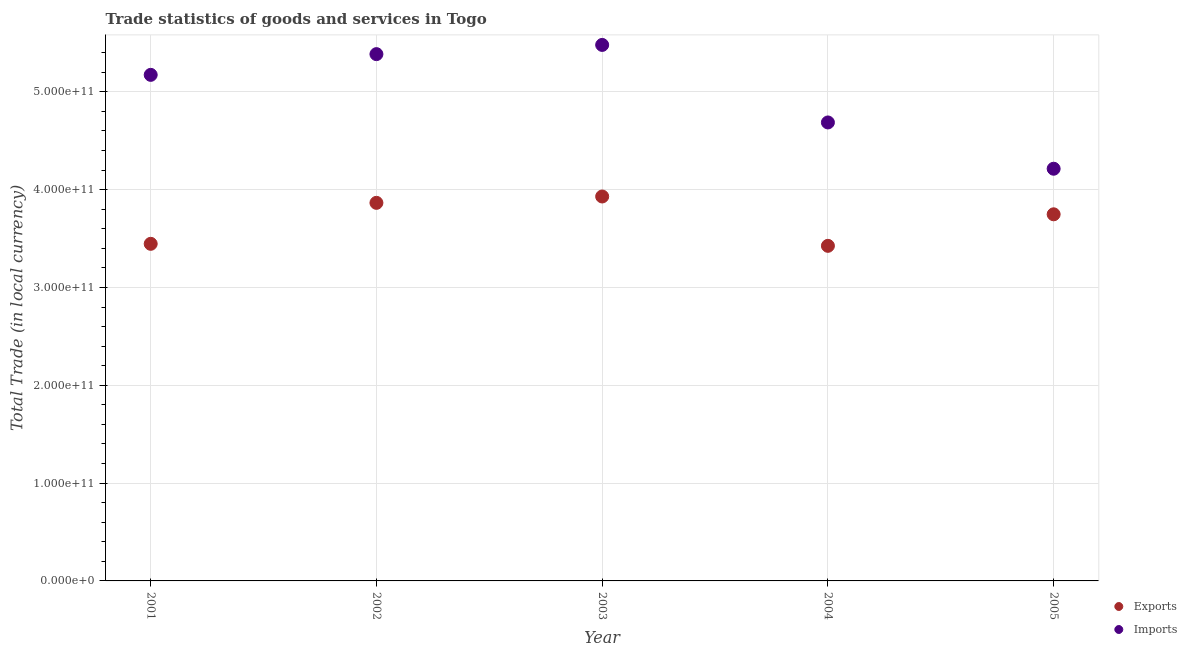How many different coloured dotlines are there?
Ensure brevity in your answer.  2. Is the number of dotlines equal to the number of legend labels?
Offer a terse response. Yes. What is the export of goods and services in 2001?
Give a very brief answer. 3.45e+11. Across all years, what is the maximum export of goods and services?
Give a very brief answer. 3.93e+11. Across all years, what is the minimum export of goods and services?
Make the answer very short. 3.43e+11. In which year was the imports of goods and services maximum?
Offer a terse response. 2003. What is the total imports of goods and services in the graph?
Your response must be concise. 2.49e+12. What is the difference between the imports of goods and services in 2002 and that in 2005?
Make the answer very short. 1.17e+11. What is the difference between the export of goods and services in 2004 and the imports of goods and services in 2005?
Offer a very short reply. -7.88e+1. What is the average export of goods and services per year?
Your answer should be compact. 3.68e+11. In the year 2004, what is the difference between the imports of goods and services and export of goods and services?
Offer a terse response. 1.26e+11. What is the ratio of the export of goods and services in 2001 to that in 2002?
Provide a short and direct response. 0.89. What is the difference between the highest and the second highest imports of goods and services?
Your answer should be very brief. 9.42e+09. What is the difference between the highest and the lowest imports of goods and services?
Your answer should be compact. 1.27e+11. Is the export of goods and services strictly less than the imports of goods and services over the years?
Offer a terse response. Yes. How many dotlines are there?
Provide a short and direct response. 2. What is the difference between two consecutive major ticks on the Y-axis?
Your answer should be compact. 1.00e+11. Does the graph contain any zero values?
Ensure brevity in your answer.  No. Does the graph contain grids?
Offer a very short reply. Yes. Where does the legend appear in the graph?
Offer a terse response. Bottom right. How many legend labels are there?
Your answer should be compact. 2. How are the legend labels stacked?
Give a very brief answer. Vertical. What is the title of the graph?
Keep it short and to the point. Trade statistics of goods and services in Togo. Does "Banks" appear as one of the legend labels in the graph?
Offer a very short reply. No. What is the label or title of the Y-axis?
Give a very brief answer. Total Trade (in local currency). What is the Total Trade (in local currency) in Exports in 2001?
Offer a terse response. 3.45e+11. What is the Total Trade (in local currency) of Imports in 2001?
Ensure brevity in your answer.  5.17e+11. What is the Total Trade (in local currency) in Exports in 2002?
Provide a short and direct response. 3.87e+11. What is the Total Trade (in local currency) in Imports in 2002?
Your answer should be compact. 5.39e+11. What is the Total Trade (in local currency) of Exports in 2003?
Your answer should be compact. 3.93e+11. What is the Total Trade (in local currency) of Imports in 2003?
Offer a terse response. 5.48e+11. What is the Total Trade (in local currency) of Exports in 2004?
Make the answer very short. 3.43e+11. What is the Total Trade (in local currency) in Imports in 2004?
Make the answer very short. 4.69e+11. What is the Total Trade (in local currency) in Exports in 2005?
Your answer should be very brief. 3.75e+11. What is the Total Trade (in local currency) of Imports in 2005?
Offer a terse response. 4.21e+11. Across all years, what is the maximum Total Trade (in local currency) of Exports?
Your answer should be compact. 3.93e+11. Across all years, what is the maximum Total Trade (in local currency) in Imports?
Make the answer very short. 5.48e+11. Across all years, what is the minimum Total Trade (in local currency) in Exports?
Provide a succinct answer. 3.43e+11. Across all years, what is the minimum Total Trade (in local currency) in Imports?
Provide a short and direct response. 4.21e+11. What is the total Total Trade (in local currency) in Exports in the graph?
Provide a succinct answer. 1.84e+12. What is the total Total Trade (in local currency) in Imports in the graph?
Provide a short and direct response. 2.49e+12. What is the difference between the Total Trade (in local currency) of Exports in 2001 and that in 2002?
Provide a short and direct response. -4.19e+1. What is the difference between the Total Trade (in local currency) of Imports in 2001 and that in 2002?
Give a very brief answer. -2.12e+1. What is the difference between the Total Trade (in local currency) of Exports in 2001 and that in 2003?
Make the answer very short. -4.84e+1. What is the difference between the Total Trade (in local currency) in Imports in 2001 and that in 2003?
Give a very brief answer. -3.06e+1. What is the difference between the Total Trade (in local currency) of Exports in 2001 and that in 2004?
Provide a short and direct response. 2.05e+09. What is the difference between the Total Trade (in local currency) in Imports in 2001 and that in 2004?
Your answer should be very brief. 4.87e+1. What is the difference between the Total Trade (in local currency) of Exports in 2001 and that in 2005?
Make the answer very short. -3.02e+1. What is the difference between the Total Trade (in local currency) in Imports in 2001 and that in 2005?
Give a very brief answer. 9.60e+1. What is the difference between the Total Trade (in local currency) of Exports in 2002 and that in 2003?
Your answer should be compact. -6.49e+09. What is the difference between the Total Trade (in local currency) of Imports in 2002 and that in 2003?
Offer a very short reply. -9.42e+09. What is the difference between the Total Trade (in local currency) of Exports in 2002 and that in 2004?
Your answer should be very brief. 4.40e+1. What is the difference between the Total Trade (in local currency) of Imports in 2002 and that in 2004?
Offer a very short reply. 6.98e+1. What is the difference between the Total Trade (in local currency) of Exports in 2002 and that in 2005?
Make the answer very short. 1.17e+1. What is the difference between the Total Trade (in local currency) of Imports in 2002 and that in 2005?
Provide a succinct answer. 1.17e+11. What is the difference between the Total Trade (in local currency) of Exports in 2003 and that in 2004?
Offer a terse response. 5.04e+1. What is the difference between the Total Trade (in local currency) of Imports in 2003 and that in 2004?
Give a very brief answer. 7.93e+1. What is the difference between the Total Trade (in local currency) in Exports in 2003 and that in 2005?
Provide a short and direct response. 1.82e+1. What is the difference between the Total Trade (in local currency) of Imports in 2003 and that in 2005?
Offer a very short reply. 1.27e+11. What is the difference between the Total Trade (in local currency) in Exports in 2004 and that in 2005?
Keep it short and to the point. -3.22e+1. What is the difference between the Total Trade (in local currency) in Imports in 2004 and that in 2005?
Offer a very short reply. 4.73e+1. What is the difference between the Total Trade (in local currency) of Exports in 2001 and the Total Trade (in local currency) of Imports in 2002?
Offer a terse response. -1.94e+11. What is the difference between the Total Trade (in local currency) of Exports in 2001 and the Total Trade (in local currency) of Imports in 2003?
Provide a short and direct response. -2.03e+11. What is the difference between the Total Trade (in local currency) of Exports in 2001 and the Total Trade (in local currency) of Imports in 2004?
Offer a terse response. -1.24e+11. What is the difference between the Total Trade (in local currency) in Exports in 2001 and the Total Trade (in local currency) in Imports in 2005?
Your answer should be compact. -7.68e+1. What is the difference between the Total Trade (in local currency) of Exports in 2002 and the Total Trade (in local currency) of Imports in 2003?
Keep it short and to the point. -1.61e+11. What is the difference between the Total Trade (in local currency) in Exports in 2002 and the Total Trade (in local currency) in Imports in 2004?
Ensure brevity in your answer.  -8.22e+1. What is the difference between the Total Trade (in local currency) in Exports in 2002 and the Total Trade (in local currency) in Imports in 2005?
Make the answer very short. -3.49e+1. What is the difference between the Total Trade (in local currency) in Exports in 2003 and the Total Trade (in local currency) in Imports in 2004?
Give a very brief answer. -7.57e+1. What is the difference between the Total Trade (in local currency) in Exports in 2003 and the Total Trade (in local currency) in Imports in 2005?
Offer a terse response. -2.84e+1. What is the difference between the Total Trade (in local currency) in Exports in 2004 and the Total Trade (in local currency) in Imports in 2005?
Make the answer very short. -7.88e+1. What is the average Total Trade (in local currency) of Exports per year?
Provide a short and direct response. 3.68e+11. What is the average Total Trade (in local currency) in Imports per year?
Provide a short and direct response. 4.99e+11. In the year 2001, what is the difference between the Total Trade (in local currency) in Exports and Total Trade (in local currency) in Imports?
Your answer should be compact. -1.73e+11. In the year 2002, what is the difference between the Total Trade (in local currency) in Exports and Total Trade (in local currency) in Imports?
Offer a very short reply. -1.52e+11. In the year 2003, what is the difference between the Total Trade (in local currency) in Exports and Total Trade (in local currency) in Imports?
Give a very brief answer. -1.55e+11. In the year 2004, what is the difference between the Total Trade (in local currency) in Exports and Total Trade (in local currency) in Imports?
Provide a short and direct response. -1.26e+11. In the year 2005, what is the difference between the Total Trade (in local currency) in Exports and Total Trade (in local currency) in Imports?
Give a very brief answer. -4.66e+1. What is the ratio of the Total Trade (in local currency) in Exports in 2001 to that in 2002?
Your answer should be compact. 0.89. What is the ratio of the Total Trade (in local currency) in Imports in 2001 to that in 2002?
Give a very brief answer. 0.96. What is the ratio of the Total Trade (in local currency) of Exports in 2001 to that in 2003?
Your answer should be compact. 0.88. What is the ratio of the Total Trade (in local currency) of Imports in 2001 to that in 2003?
Your answer should be compact. 0.94. What is the ratio of the Total Trade (in local currency) of Imports in 2001 to that in 2004?
Make the answer very short. 1.1. What is the ratio of the Total Trade (in local currency) in Exports in 2001 to that in 2005?
Ensure brevity in your answer.  0.92. What is the ratio of the Total Trade (in local currency) of Imports in 2001 to that in 2005?
Your answer should be very brief. 1.23. What is the ratio of the Total Trade (in local currency) in Exports in 2002 to that in 2003?
Keep it short and to the point. 0.98. What is the ratio of the Total Trade (in local currency) of Imports in 2002 to that in 2003?
Provide a short and direct response. 0.98. What is the ratio of the Total Trade (in local currency) of Exports in 2002 to that in 2004?
Your response must be concise. 1.13. What is the ratio of the Total Trade (in local currency) in Imports in 2002 to that in 2004?
Provide a short and direct response. 1.15. What is the ratio of the Total Trade (in local currency) in Exports in 2002 to that in 2005?
Your answer should be very brief. 1.03. What is the ratio of the Total Trade (in local currency) of Imports in 2002 to that in 2005?
Provide a short and direct response. 1.28. What is the ratio of the Total Trade (in local currency) of Exports in 2003 to that in 2004?
Provide a short and direct response. 1.15. What is the ratio of the Total Trade (in local currency) of Imports in 2003 to that in 2004?
Your response must be concise. 1.17. What is the ratio of the Total Trade (in local currency) in Exports in 2003 to that in 2005?
Your response must be concise. 1.05. What is the ratio of the Total Trade (in local currency) of Imports in 2003 to that in 2005?
Ensure brevity in your answer.  1.3. What is the ratio of the Total Trade (in local currency) of Exports in 2004 to that in 2005?
Provide a short and direct response. 0.91. What is the ratio of the Total Trade (in local currency) in Imports in 2004 to that in 2005?
Provide a succinct answer. 1.11. What is the difference between the highest and the second highest Total Trade (in local currency) in Exports?
Offer a very short reply. 6.49e+09. What is the difference between the highest and the second highest Total Trade (in local currency) of Imports?
Make the answer very short. 9.42e+09. What is the difference between the highest and the lowest Total Trade (in local currency) of Exports?
Your answer should be very brief. 5.04e+1. What is the difference between the highest and the lowest Total Trade (in local currency) in Imports?
Make the answer very short. 1.27e+11. 